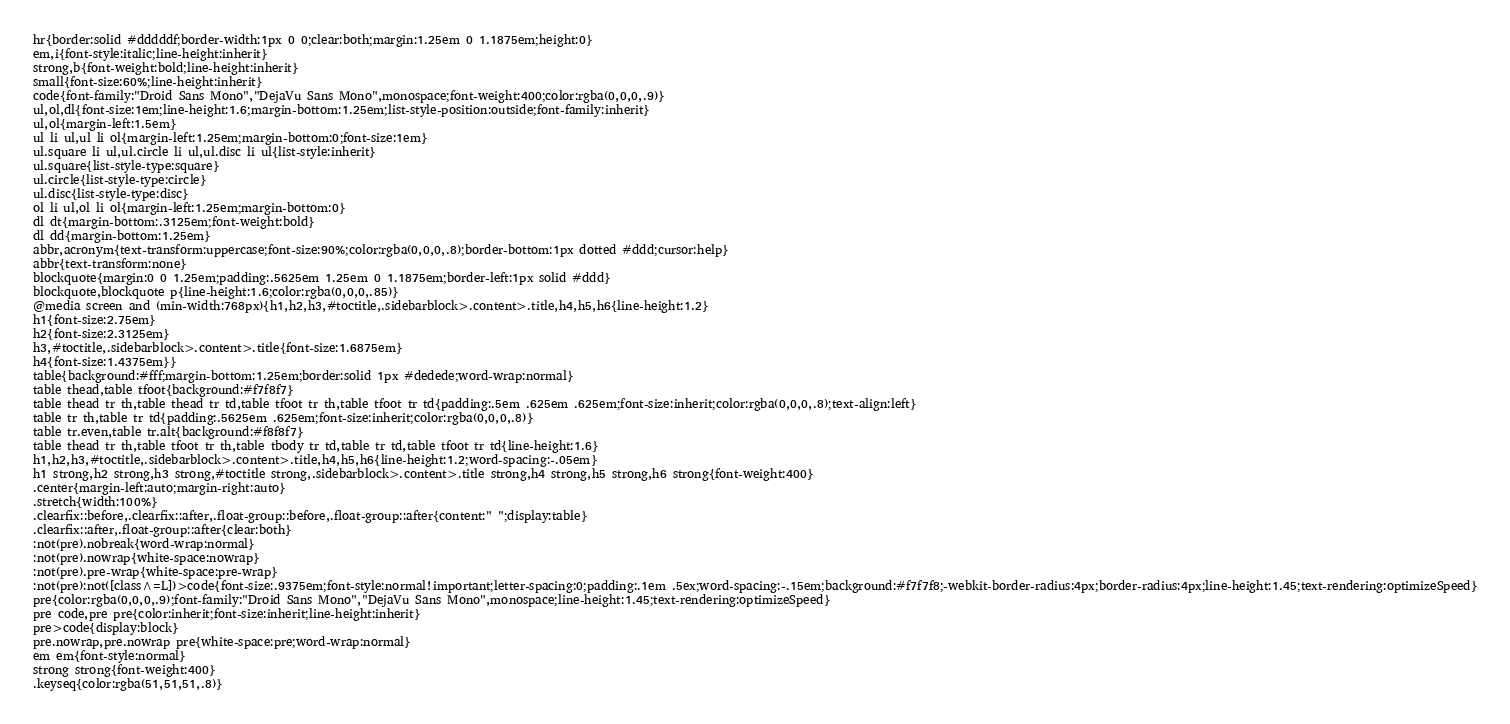Convert code to text. <code><loc_0><loc_0><loc_500><loc_500><_HTML_>hr{border:solid #dddddf;border-width:1px 0 0;clear:both;margin:1.25em 0 1.1875em;height:0}
em,i{font-style:italic;line-height:inherit}
strong,b{font-weight:bold;line-height:inherit}
small{font-size:60%;line-height:inherit}
code{font-family:"Droid Sans Mono","DejaVu Sans Mono",monospace;font-weight:400;color:rgba(0,0,0,.9)}
ul,ol,dl{font-size:1em;line-height:1.6;margin-bottom:1.25em;list-style-position:outside;font-family:inherit}
ul,ol{margin-left:1.5em}
ul li ul,ul li ol{margin-left:1.25em;margin-bottom:0;font-size:1em}
ul.square li ul,ul.circle li ul,ul.disc li ul{list-style:inherit}
ul.square{list-style-type:square}
ul.circle{list-style-type:circle}
ul.disc{list-style-type:disc}
ol li ul,ol li ol{margin-left:1.25em;margin-bottom:0}
dl dt{margin-bottom:.3125em;font-weight:bold}
dl dd{margin-bottom:1.25em}
abbr,acronym{text-transform:uppercase;font-size:90%;color:rgba(0,0,0,.8);border-bottom:1px dotted #ddd;cursor:help}
abbr{text-transform:none}
blockquote{margin:0 0 1.25em;padding:.5625em 1.25em 0 1.1875em;border-left:1px solid #ddd}
blockquote,blockquote p{line-height:1.6;color:rgba(0,0,0,.85)}
@media screen and (min-width:768px){h1,h2,h3,#toctitle,.sidebarblock>.content>.title,h4,h5,h6{line-height:1.2}
h1{font-size:2.75em}
h2{font-size:2.3125em}
h3,#toctitle,.sidebarblock>.content>.title{font-size:1.6875em}
h4{font-size:1.4375em}}
table{background:#fff;margin-bottom:1.25em;border:solid 1px #dedede;word-wrap:normal}
table thead,table tfoot{background:#f7f8f7}
table thead tr th,table thead tr td,table tfoot tr th,table tfoot tr td{padding:.5em .625em .625em;font-size:inherit;color:rgba(0,0,0,.8);text-align:left}
table tr th,table tr td{padding:.5625em .625em;font-size:inherit;color:rgba(0,0,0,.8)}
table tr.even,table tr.alt{background:#f8f8f7}
table thead tr th,table tfoot tr th,table tbody tr td,table tr td,table tfoot tr td{line-height:1.6}
h1,h2,h3,#toctitle,.sidebarblock>.content>.title,h4,h5,h6{line-height:1.2;word-spacing:-.05em}
h1 strong,h2 strong,h3 strong,#toctitle strong,.sidebarblock>.content>.title strong,h4 strong,h5 strong,h6 strong{font-weight:400}
.center{margin-left:auto;margin-right:auto}
.stretch{width:100%}
.clearfix::before,.clearfix::after,.float-group::before,.float-group::after{content:" ";display:table}
.clearfix::after,.float-group::after{clear:both}
:not(pre).nobreak{word-wrap:normal}
:not(pre).nowrap{white-space:nowrap}
:not(pre).pre-wrap{white-space:pre-wrap}
:not(pre):not([class^=L])>code{font-size:.9375em;font-style:normal!important;letter-spacing:0;padding:.1em .5ex;word-spacing:-.15em;background:#f7f7f8;-webkit-border-radius:4px;border-radius:4px;line-height:1.45;text-rendering:optimizeSpeed}
pre{color:rgba(0,0,0,.9);font-family:"Droid Sans Mono","DejaVu Sans Mono",monospace;line-height:1.45;text-rendering:optimizeSpeed}
pre code,pre pre{color:inherit;font-size:inherit;line-height:inherit}
pre>code{display:block}
pre.nowrap,pre.nowrap pre{white-space:pre;word-wrap:normal}
em em{font-style:normal}
strong strong{font-weight:400}
.keyseq{color:rgba(51,51,51,.8)}</code> 